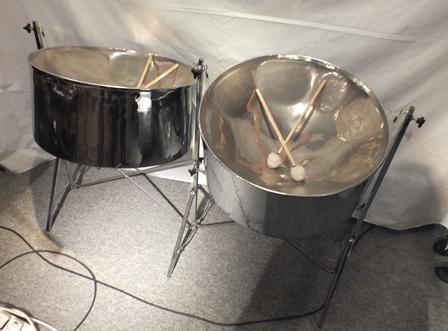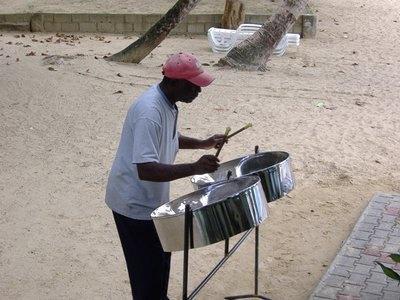The first image is the image on the left, the second image is the image on the right. Examine the images to the left and right. Is the description "At least one steel drum has drum sticks laying on top." accurate? Answer yes or no. Yes. The first image is the image on the left, the second image is the image on the right. For the images shown, is this caption "In at least one image there is a total of two drums and one man playing them." true? Answer yes or no. Yes. 